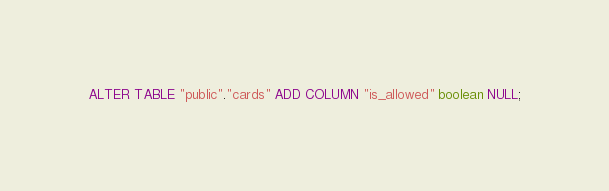Convert code to text. <code><loc_0><loc_0><loc_500><loc_500><_SQL_>ALTER TABLE "public"."cards" ADD COLUMN "is_allowed" boolean NULL;
</code> 